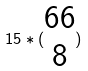<formula> <loc_0><loc_0><loc_500><loc_500>1 5 * ( \begin{matrix} 6 6 \\ 8 \end{matrix} )</formula> 